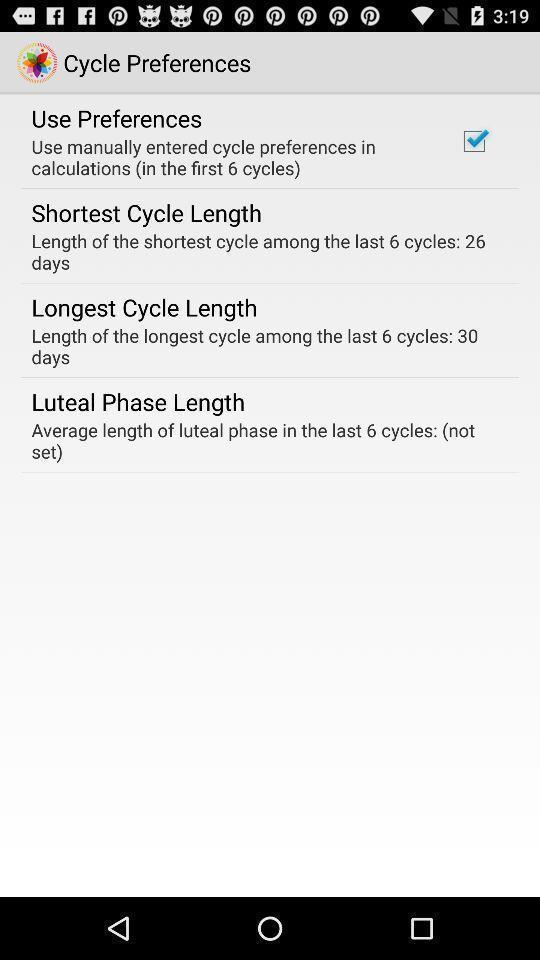Summarize the information in this screenshot. Page shows settings options of cycle preference on health app. 